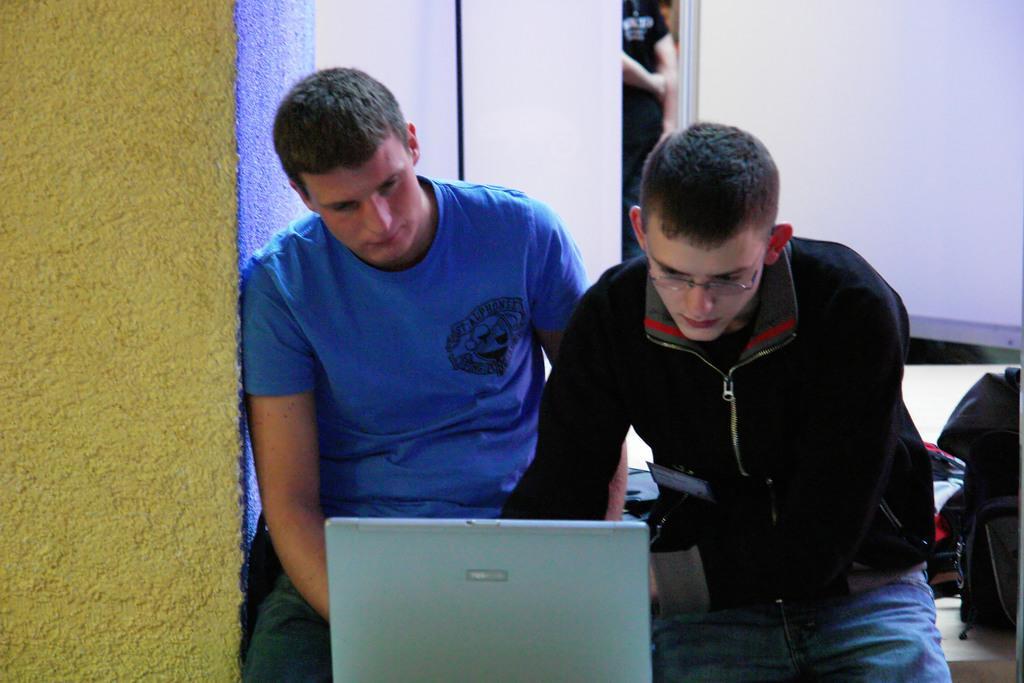Describe this image in one or two sentences. In this picture I can see there are two men sitting and they are operating a laptop and there is a pillar at left side. 